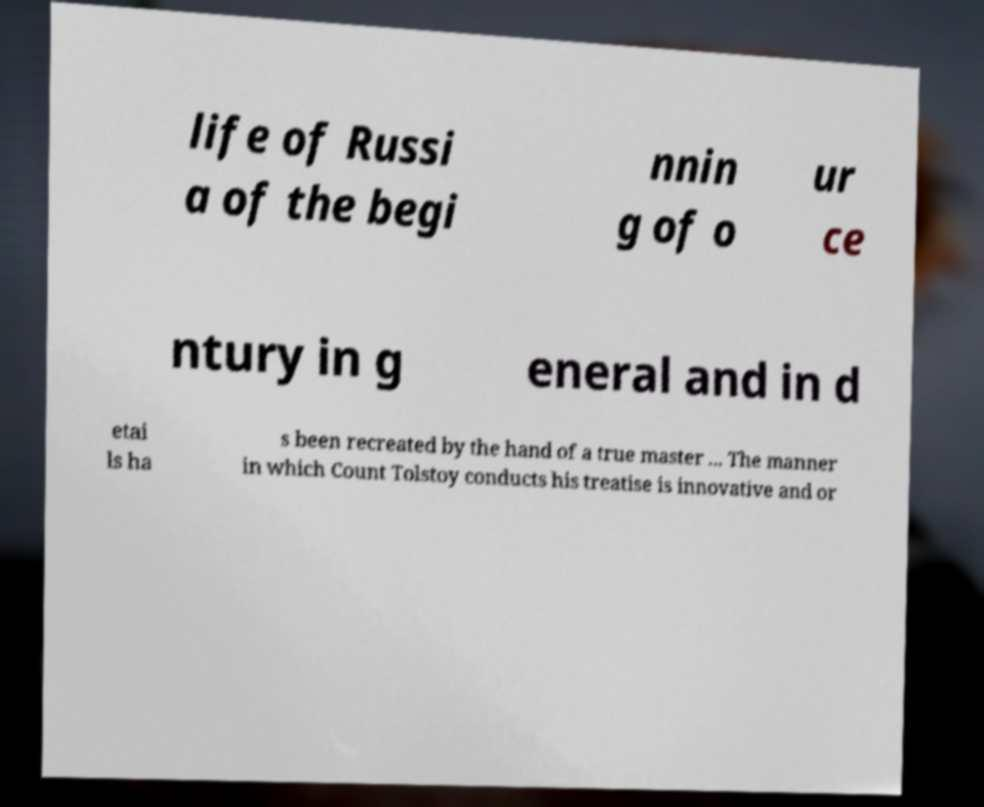Could you assist in decoding the text presented in this image and type it out clearly? life of Russi a of the begi nnin g of o ur ce ntury in g eneral and in d etai ls ha s been recreated by the hand of a true master ... The manner in which Count Tolstoy conducts his treatise is innovative and or 